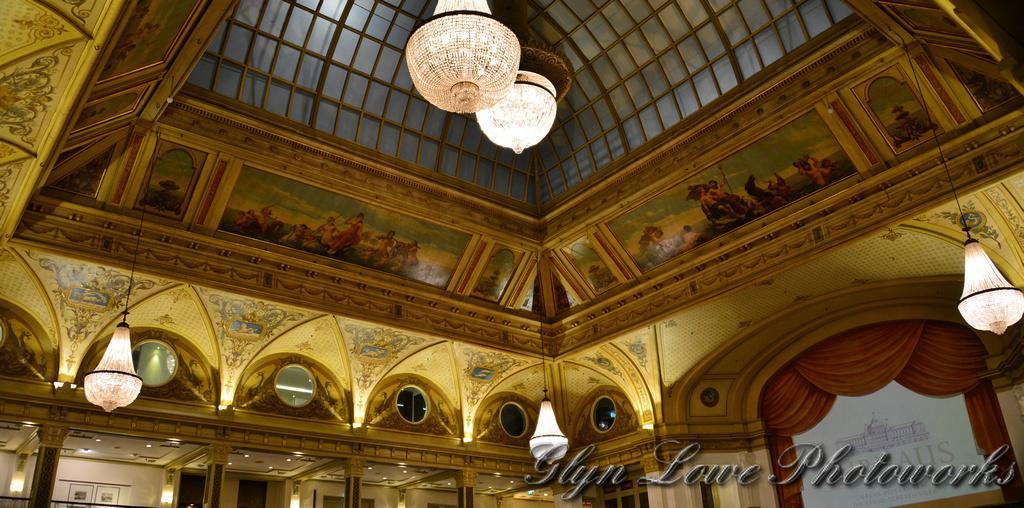Could you give a brief overview of what you see in this image? In this image, I can see the inside view of a building. There are chandeliers hanging to a ceiling and I can see the photo frames and mirrors to the wall. At the bottom of the image, I can see the ceiling lights and pillars. In the bottom right side of the image, I can see a watermark. 